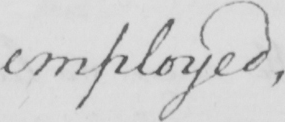What text is written in this handwritten line? employed , 